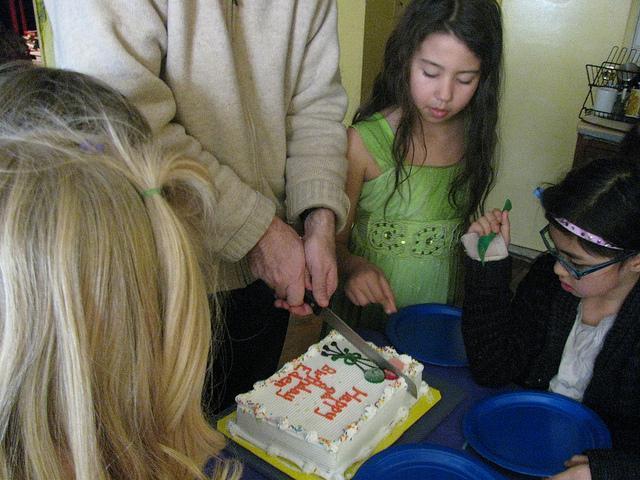How many people can you see?
Give a very brief answer. 4. How many giraffes are there in the grass?
Give a very brief answer. 0. 